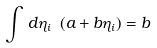Convert formula to latex. <formula><loc_0><loc_0><loc_500><loc_500>\int \, d \eta _ { i } \ ( a + b \eta _ { i } ) = b</formula> 